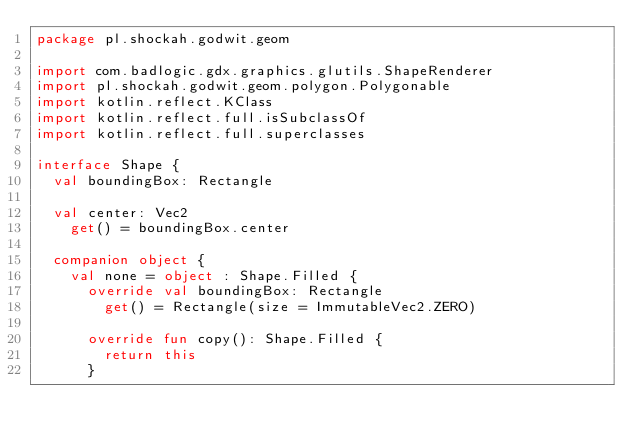<code> <loc_0><loc_0><loc_500><loc_500><_Kotlin_>package pl.shockah.godwit.geom

import com.badlogic.gdx.graphics.glutils.ShapeRenderer
import pl.shockah.godwit.geom.polygon.Polygonable
import kotlin.reflect.KClass
import kotlin.reflect.full.isSubclassOf
import kotlin.reflect.full.superclasses

interface Shape {
	val boundingBox: Rectangle

	val center: Vec2
		get() = boundingBox.center

	companion object {
		val none = object : Shape.Filled {
			override val boundingBox: Rectangle
				get() = Rectangle(size = ImmutableVec2.ZERO)

			override fun copy(): Shape.Filled {
				return this
			}
</code> 